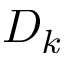Convert formula to latex. <formula><loc_0><loc_0><loc_500><loc_500>D _ { k }</formula> 